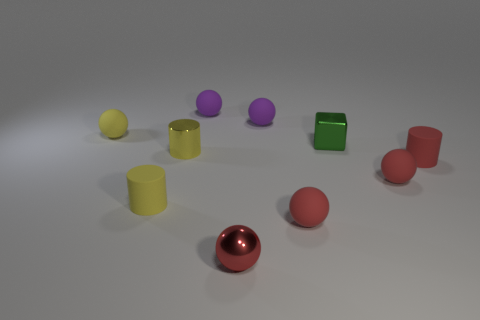Subtract all yellow cylinders. How many red spheres are left? 3 Subtract all yellow balls. How many balls are left? 5 Subtract all yellow spheres. How many spheres are left? 5 Subtract all gray spheres. Subtract all brown cylinders. How many spheres are left? 6 Subtract all cubes. How many objects are left? 9 Add 7 small red shiny objects. How many small red shiny objects exist? 8 Subtract 0 blue cubes. How many objects are left? 10 Subtract all tiny green shiny cubes. Subtract all small metal cylinders. How many objects are left? 8 Add 1 green shiny cubes. How many green shiny cubes are left? 2 